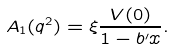Convert formula to latex. <formula><loc_0><loc_0><loc_500><loc_500>A _ { 1 } ( q ^ { 2 } ) = \xi \frac { V ( 0 ) } { 1 - b ^ { \prime } x } .</formula> 